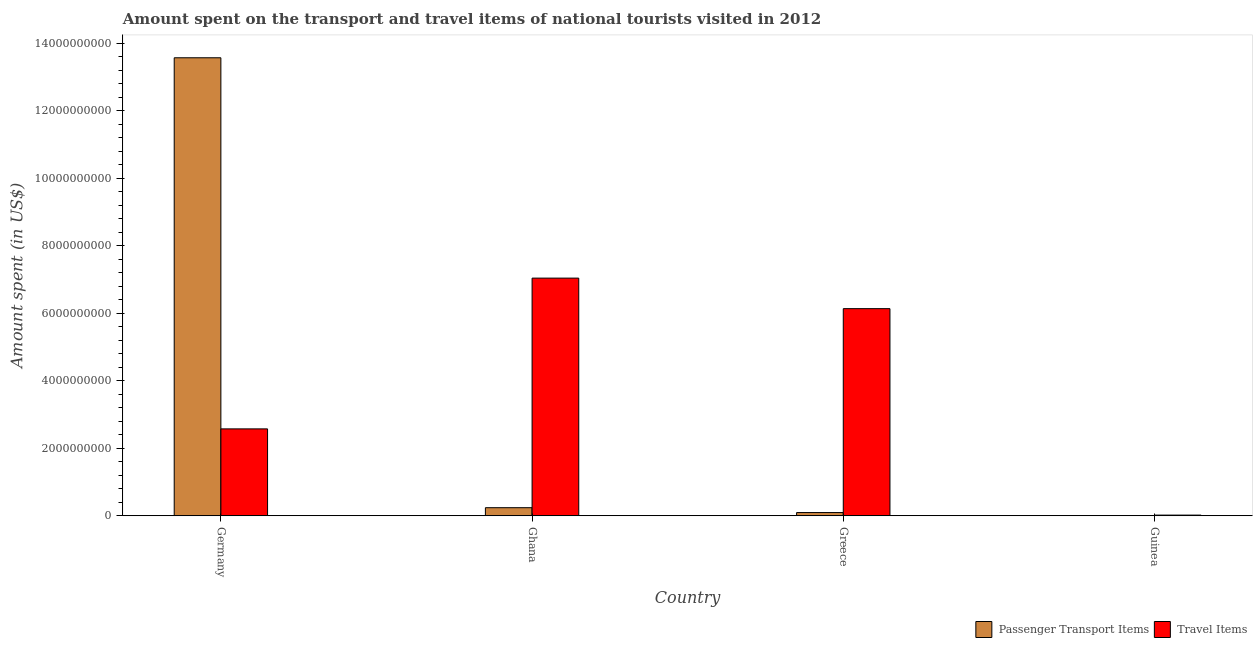How many bars are there on the 3rd tick from the left?
Offer a very short reply. 2. What is the label of the 3rd group of bars from the left?
Ensure brevity in your answer.  Greece. What is the amount spent in travel items in Ghana?
Your response must be concise. 7.04e+09. Across all countries, what is the maximum amount spent on passenger transport items?
Give a very brief answer. 1.36e+1. Across all countries, what is the minimum amount spent in travel items?
Your response must be concise. 2.05e+07. In which country was the amount spent on passenger transport items maximum?
Your answer should be compact. Germany. In which country was the amount spent in travel items minimum?
Provide a short and direct response. Guinea. What is the total amount spent on passenger transport items in the graph?
Your response must be concise. 1.39e+1. What is the difference between the amount spent in travel items in Ghana and that in Guinea?
Keep it short and to the point. 7.02e+09. What is the difference between the amount spent in travel items in Ghana and the amount spent on passenger transport items in Greece?
Give a very brief answer. 6.94e+09. What is the average amount spent on passenger transport items per country?
Offer a terse response. 3.48e+09. What is the difference between the amount spent on passenger transport items and amount spent in travel items in Germany?
Your answer should be very brief. 1.10e+1. What is the ratio of the amount spent on passenger transport items in Germany to that in Greece?
Your answer should be compact. 141.3. Is the amount spent in travel items in Germany less than that in Ghana?
Give a very brief answer. Yes. What is the difference between the highest and the second highest amount spent in travel items?
Ensure brevity in your answer.  9.04e+08. What is the difference between the highest and the lowest amount spent in travel items?
Make the answer very short. 7.02e+09. In how many countries, is the amount spent in travel items greater than the average amount spent in travel items taken over all countries?
Keep it short and to the point. 2. Is the sum of the amount spent on passenger transport items in Germany and Guinea greater than the maximum amount spent in travel items across all countries?
Make the answer very short. Yes. What does the 2nd bar from the left in Ghana represents?
Keep it short and to the point. Travel Items. What does the 1st bar from the right in Ghana represents?
Keep it short and to the point. Travel Items. How many countries are there in the graph?
Make the answer very short. 4. Does the graph contain grids?
Offer a very short reply. No. How many legend labels are there?
Provide a short and direct response. 2. What is the title of the graph?
Your response must be concise. Amount spent on the transport and travel items of national tourists visited in 2012. Does "Resident" appear as one of the legend labels in the graph?
Ensure brevity in your answer.  No. What is the label or title of the Y-axis?
Your answer should be compact. Amount spent (in US$). What is the Amount spent (in US$) of Passenger Transport Items in Germany?
Make the answer very short. 1.36e+1. What is the Amount spent (in US$) in Travel Items in Germany?
Make the answer very short. 2.57e+09. What is the Amount spent (in US$) of Passenger Transport Items in Ghana?
Your response must be concise. 2.40e+08. What is the Amount spent (in US$) in Travel Items in Ghana?
Your answer should be compact. 7.04e+09. What is the Amount spent (in US$) in Passenger Transport Items in Greece?
Provide a succinct answer. 9.60e+07. What is the Amount spent (in US$) in Travel Items in Greece?
Keep it short and to the point. 6.14e+09. What is the Amount spent (in US$) of Passenger Transport Items in Guinea?
Provide a succinct answer. 3.00e+05. What is the Amount spent (in US$) of Travel Items in Guinea?
Your answer should be very brief. 2.05e+07. Across all countries, what is the maximum Amount spent (in US$) of Passenger Transport Items?
Your answer should be compact. 1.36e+1. Across all countries, what is the maximum Amount spent (in US$) of Travel Items?
Offer a terse response. 7.04e+09. Across all countries, what is the minimum Amount spent (in US$) in Travel Items?
Ensure brevity in your answer.  2.05e+07. What is the total Amount spent (in US$) in Passenger Transport Items in the graph?
Make the answer very short. 1.39e+1. What is the total Amount spent (in US$) in Travel Items in the graph?
Offer a terse response. 1.58e+1. What is the difference between the Amount spent (in US$) of Passenger Transport Items in Germany and that in Ghana?
Ensure brevity in your answer.  1.33e+1. What is the difference between the Amount spent (in US$) in Travel Items in Germany and that in Ghana?
Your answer should be very brief. -4.46e+09. What is the difference between the Amount spent (in US$) in Passenger Transport Items in Germany and that in Greece?
Offer a very short reply. 1.35e+1. What is the difference between the Amount spent (in US$) in Travel Items in Germany and that in Greece?
Offer a very short reply. -3.56e+09. What is the difference between the Amount spent (in US$) of Passenger Transport Items in Germany and that in Guinea?
Give a very brief answer. 1.36e+1. What is the difference between the Amount spent (in US$) of Travel Items in Germany and that in Guinea?
Your answer should be very brief. 2.55e+09. What is the difference between the Amount spent (in US$) in Passenger Transport Items in Ghana and that in Greece?
Your answer should be compact. 1.44e+08. What is the difference between the Amount spent (in US$) in Travel Items in Ghana and that in Greece?
Ensure brevity in your answer.  9.04e+08. What is the difference between the Amount spent (in US$) of Passenger Transport Items in Ghana and that in Guinea?
Make the answer very short. 2.40e+08. What is the difference between the Amount spent (in US$) in Travel Items in Ghana and that in Guinea?
Provide a short and direct response. 7.02e+09. What is the difference between the Amount spent (in US$) in Passenger Transport Items in Greece and that in Guinea?
Offer a terse response. 9.57e+07. What is the difference between the Amount spent (in US$) in Travel Items in Greece and that in Guinea?
Your answer should be very brief. 6.11e+09. What is the difference between the Amount spent (in US$) of Passenger Transport Items in Germany and the Amount spent (in US$) of Travel Items in Ghana?
Offer a very short reply. 6.53e+09. What is the difference between the Amount spent (in US$) in Passenger Transport Items in Germany and the Amount spent (in US$) in Travel Items in Greece?
Your answer should be very brief. 7.43e+09. What is the difference between the Amount spent (in US$) in Passenger Transport Items in Germany and the Amount spent (in US$) in Travel Items in Guinea?
Your response must be concise. 1.35e+1. What is the difference between the Amount spent (in US$) in Passenger Transport Items in Ghana and the Amount spent (in US$) in Travel Items in Greece?
Provide a short and direct response. -5.90e+09. What is the difference between the Amount spent (in US$) of Passenger Transport Items in Ghana and the Amount spent (in US$) of Travel Items in Guinea?
Offer a terse response. 2.20e+08. What is the difference between the Amount spent (in US$) of Passenger Transport Items in Greece and the Amount spent (in US$) of Travel Items in Guinea?
Your response must be concise. 7.55e+07. What is the average Amount spent (in US$) of Passenger Transport Items per country?
Your response must be concise. 3.48e+09. What is the average Amount spent (in US$) of Travel Items per country?
Provide a succinct answer. 3.94e+09. What is the difference between the Amount spent (in US$) of Passenger Transport Items and Amount spent (in US$) of Travel Items in Germany?
Your answer should be compact. 1.10e+1. What is the difference between the Amount spent (in US$) of Passenger Transport Items and Amount spent (in US$) of Travel Items in Ghana?
Provide a short and direct response. -6.80e+09. What is the difference between the Amount spent (in US$) of Passenger Transport Items and Amount spent (in US$) of Travel Items in Greece?
Keep it short and to the point. -6.04e+09. What is the difference between the Amount spent (in US$) of Passenger Transport Items and Amount spent (in US$) of Travel Items in Guinea?
Provide a succinct answer. -2.02e+07. What is the ratio of the Amount spent (in US$) in Passenger Transport Items in Germany to that in Ghana?
Offer a terse response. 56.52. What is the ratio of the Amount spent (in US$) of Travel Items in Germany to that in Ghana?
Provide a short and direct response. 0.37. What is the ratio of the Amount spent (in US$) of Passenger Transport Items in Germany to that in Greece?
Give a very brief answer. 141.3. What is the ratio of the Amount spent (in US$) in Travel Items in Germany to that in Greece?
Provide a short and direct response. 0.42. What is the ratio of the Amount spent (in US$) of Passenger Transport Items in Germany to that in Guinea?
Provide a short and direct response. 4.52e+04. What is the ratio of the Amount spent (in US$) in Travel Items in Germany to that in Guinea?
Your answer should be very brief. 125.56. What is the ratio of the Amount spent (in US$) in Travel Items in Ghana to that in Greece?
Keep it short and to the point. 1.15. What is the ratio of the Amount spent (in US$) in Passenger Transport Items in Ghana to that in Guinea?
Give a very brief answer. 800. What is the ratio of the Amount spent (in US$) of Travel Items in Ghana to that in Guinea?
Provide a succinct answer. 343.37. What is the ratio of the Amount spent (in US$) in Passenger Transport Items in Greece to that in Guinea?
Provide a short and direct response. 320. What is the ratio of the Amount spent (in US$) of Travel Items in Greece to that in Guinea?
Keep it short and to the point. 299.27. What is the difference between the highest and the second highest Amount spent (in US$) in Passenger Transport Items?
Offer a very short reply. 1.33e+1. What is the difference between the highest and the second highest Amount spent (in US$) in Travel Items?
Provide a succinct answer. 9.04e+08. What is the difference between the highest and the lowest Amount spent (in US$) of Passenger Transport Items?
Offer a very short reply. 1.36e+1. What is the difference between the highest and the lowest Amount spent (in US$) in Travel Items?
Your response must be concise. 7.02e+09. 